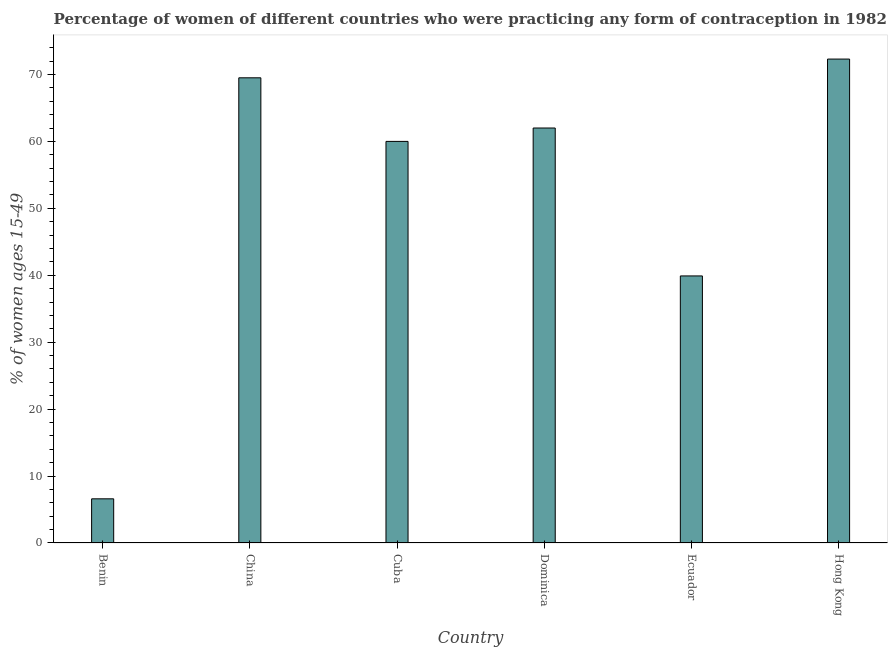Does the graph contain any zero values?
Your response must be concise. No. Does the graph contain grids?
Your response must be concise. No. What is the title of the graph?
Provide a succinct answer. Percentage of women of different countries who were practicing any form of contraception in 1982. What is the label or title of the X-axis?
Make the answer very short. Country. What is the label or title of the Y-axis?
Your answer should be compact. % of women ages 15-49. What is the contraceptive prevalence in Cuba?
Offer a terse response. 60. Across all countries, what is the maximum contraceptive prevalence?
Ensure brevity in your answer.  72.3. In which country was the contraceptive prevalence maximum?
Offer a terse response. Hong Kong. In which country was the contraceptive prevalence minimum?
Offer a very short reply. Benin. What is the sum of the contraceptive prevalence?
Make the answer very short. 310.3. What is the difference between the contraceptive prevalence in China and Hong Kong?
Ensure brevity in your answer.  -2.8. What is the average contraceptive prevalence per country?
Provide a succinct answer. 51.72. What is the ratio of the contraceptive prevalence in China to that in Ecuador?
Offer a terse response. 1.74. Is the contraceptive prevalence in Dominica less than that in Hong Kong?
Your answer should be very brief. Yes. Is the difference between the contraceptive prevalence in Cuba and Ecuador greater than the difference between any two countries?
Your answer should be compact. No. What is the difference between the highest and the second highest contraceptive prevalence?
Your response must be concise. 2.8. What is the difference between the highest and the lowest contraceptive prevalence?
Your answer should be very brief. 65.7. In how many countries, is the contraceptive prevalence greater than the average contraceptive prevalence taken over all countries?
Offer a very short reply. 4. How many countries are there in the graph?
Keep it short and to the point. 6. What is the % of women ages 15-49 in China?
Offer a terse response. 69.5. What is the % of women ages 15-49 in Cuba?
Provide a succinct answer. 60. What is the % of women ages 15-49 in Dominica?
Ensure brevity in your answer.  62. What is the % of women ages 15-49 of Ecuador?
Your answer should be compact. 39.9. What is the % of women ages 15-49 in Hong Kong?
Make the answer very short. 72.3. What is the difference between the % of women ages 15-49 in Benin and China?
Provide a succinct answer. -62.9. What is the difference between the % of women ages 15-49 in Benin and Cuba?
Your answer should be compact. -53.4. What is the difference between the % of women ages 15-49 in Benin and Dominica?
Provide a short and direct response. -55.4. What is the difference between the % of women ages 15-49 in Benin and Ecuador?
Your response must be concise. -33.3. What is the difference between the % of women ages 15-49 in Benin and Hong Kong?
Give a very brief answer. -65.7. What is the difference between the % of women ages 15-49 in China and Cuba?
Your answer should be very brief. 9.5. What is the difference between the % of women ages 15-49 in China and Dominica?
Keep it short and to the point. 7.5. What is the difference between the % of women ages 15-49 in China and Ecuador?
Give a very brief answer. 29.6. What is the difference between the % of women ages 15-49 in China and Hong Kong?
Offer a very short reply. -2.8. What is the difference between the % of women ages 15-49 in Cuba and Ecuador?
Your answer should be very brief. 20.1. What is the difference between the % of women ages 15-49 in Cuba and Hong Kong?
Your response must be concise. -12.3. What is the difference between the % of women ages 15-49 in Dominica and Ecuador?
Offer a very short reply. 22.1. What is the difference between the % of women ages 15-49 in Ecuador and Hong Kong?
Make the answer very short. -32.4. What is the ratio of the % of women ages 15-49 in Benin to that in China?
Keep it short and to the point. 0.1. What is the ratio of the % of women ages 15-49 in Benin to that in Cuba?
Make the answer very short. 0.11. What is the ratio of the % of women ages 15-49 in Benin to that in Dominica?
Ensure brevity in your answer.  0.11. What is the ratio of the % of women ages 15-49 in Benin to that in Ecuador?
Keep it short and to the point. 0.17. What is the ratio of the % of women ages 15-49 in Benin to that in Hong Kong?
Offer a terse response. 0.09. What is the ratio of the % of women ages 15-49 in China to that in Cuba?
Provide a short and direct response. 1.16. What is the ratio of the % of women ages 15-49 in China to that in Dominica?
Your response must be concise. 1.12. What is the ratio of the % of women ages 15-49 in China to that in Ecuador?
Your response must be concise. 1.74. What is the ratio of the % of women ages 15-49 in Cuba to that in Dominica?
Provide a succinct answer. 0.97. What is the ratio of the % of women ages 15-49 in Cuba to that in Ecuador?
Your response must be concise. 1.5. What is the ratio of the % of women ages 15-49 in Cuba to that in Hong Kong?
Make the answer very short. 0.83. What is the ratio of the % of women ages 15-49 in Dominica to that in Ecuador?
Give a very brief answer. 1.55. What is the ratio of the % of women ages 15-49 in Dominica to that in Hong Kong?
Keep it short and to the point. 0.86. What is the ratio of the % of women ages 15-49 in Ecuador to that in Hong Kong?
Give a very brief answer. 0.55. 